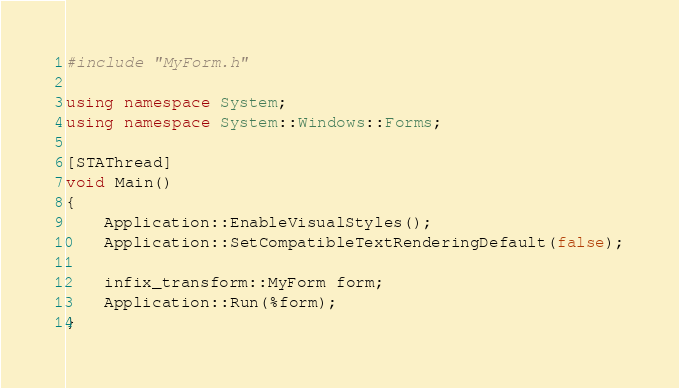<code> <loc_0><loc_0><loc_500><loc_500><_C++_>#include "MyForm.h"

using namespace System;
using namespace System::Windows::Forms;

[STAThread]
void Main()
{
	Application::EnableVisualStyles();
	Application::SetCompatibleTextRenderingDefault(false);

	infix_transform::MyForm form;
	Application::Run(%form);
}
</code> 